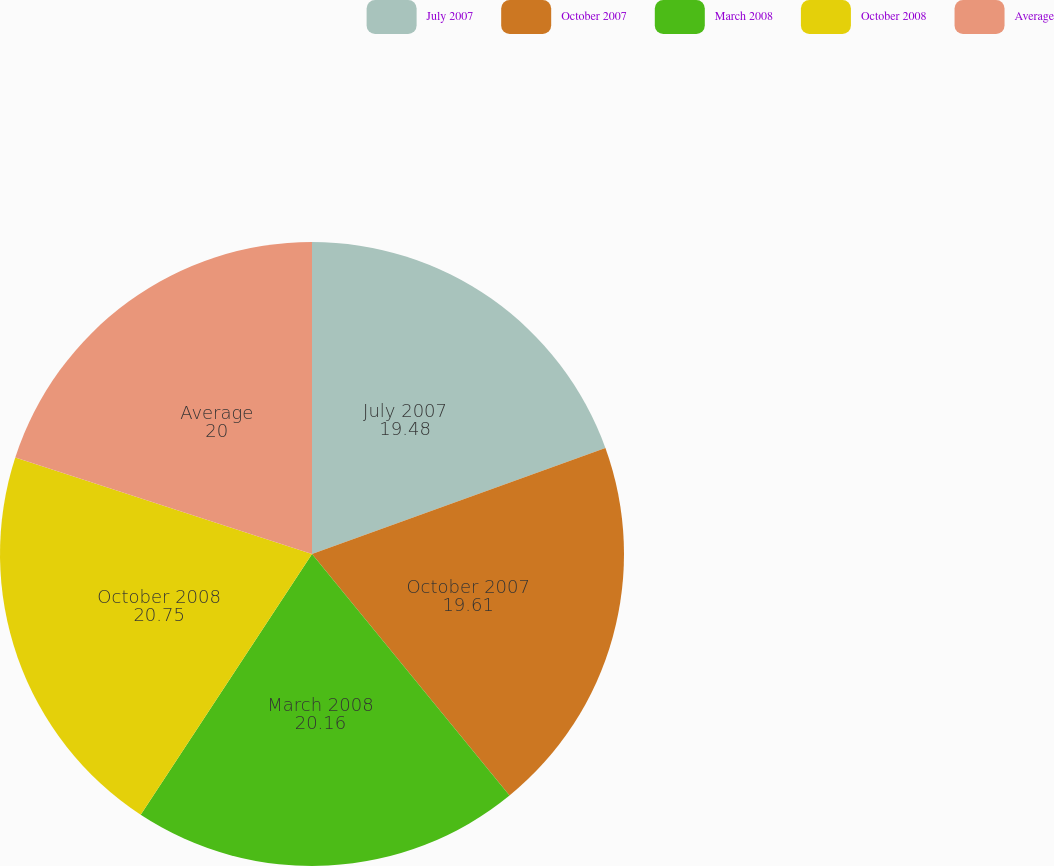<chart> <loc_0><loc_0><loc_500><loc_500><pie_chart><fcel>July 2007<fcel>October 2007<fcel>March 2008<fcel>October 2008<fcel>Average<nl><fcel>19.48%<fcel>19.61%<fcel>20.16%<fcel>20.75%<fcel>20.0%<nl></chart> 